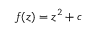Convert formula to latex. <formula><loc_0><loc_0><loc_500><loc_500>f ( z ) = z ^ { 2 } + c</formula> 